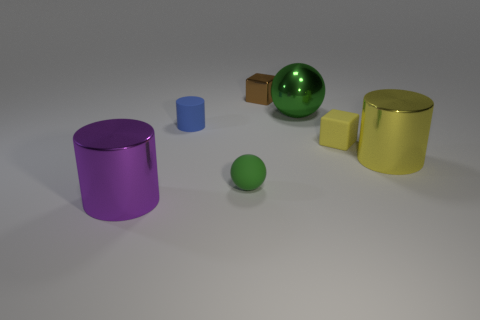Is there a green thing that has the same material as the small cylinder?
Your response must be concise. Yes. There is a blue thing that is the same size as the green rubber ball; what is its material?
Keep it short and to the point. Rubber. The cylinder that is in front of the large cylinder that is to the right of the small matte cylinder is made of what material?
Give a very brief answer. Metal. There is a big metallic object that is right of the large green object; is it the same shape as the tiny blue thing?
Provide a short and direct response. Yes. There is a sphere that is made of the same material as the purple cylinder; what color is it?
Give a very brief answer. Green. There is a big cylinder right of the big purple cylinder; what is its material?
Give a very brief answer. Metal. Is the shape of the blue rubber thing the same as the matte thing right of the small brown block?
Provide a short and direct response. No. What is the material of the cylinder that is on the right side of the large purple cylinder and in front of the blue object?
Provide a short and direct response. Metal. What color is the cube that is the same size as the yellow rubber object?
Make the answer very short. Brown. Do the small brown thing and the green thing behind the tiny yellow matte object have the same material?
Ensure brevity in your answer.  Yes. 